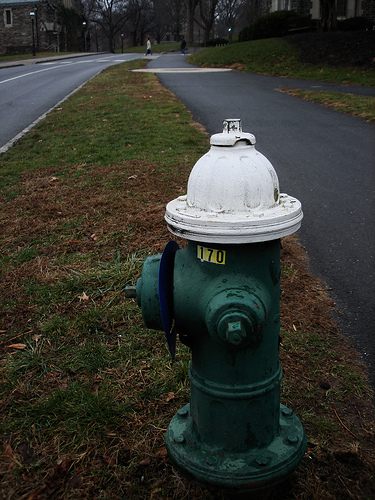Please provide the bounding box coordinate of the region this sentence describes: black street light on the side of the road. The coordinates for the black street light are [0.18, 0.01, 0.2, 0.12], appropriately highlighting the fixture's position along the roadside, an essential element for nighttime visibility and safety. 